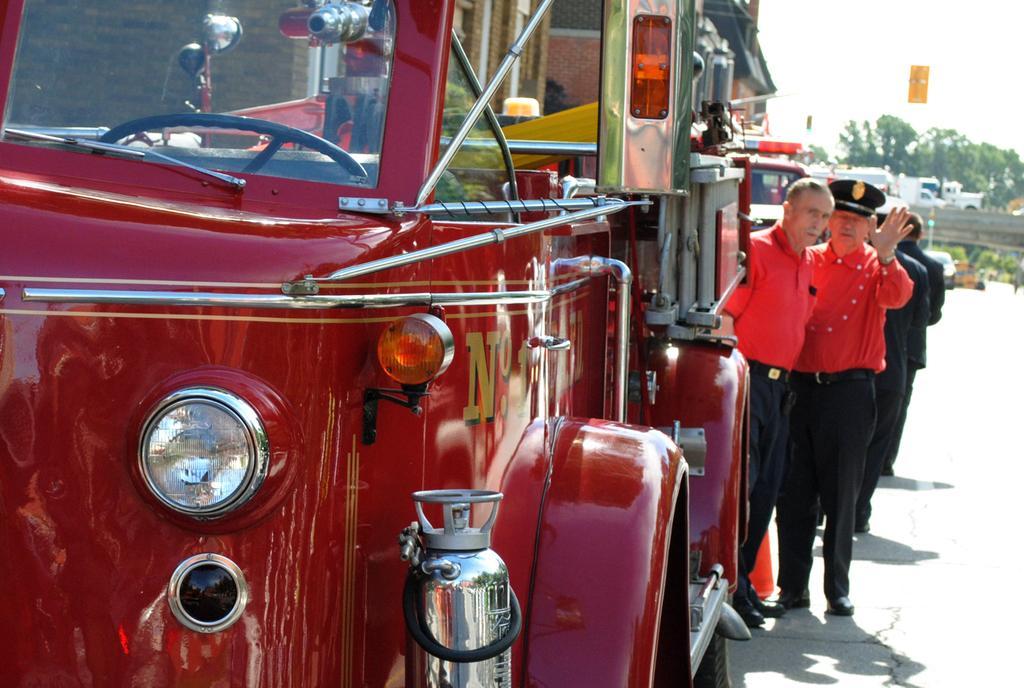Could you give a brief overview of what you see in this image? In this image, we can see people wearing wearing clothes. There are vehicles in the middle of the image. There are trees in the top right of the image. 